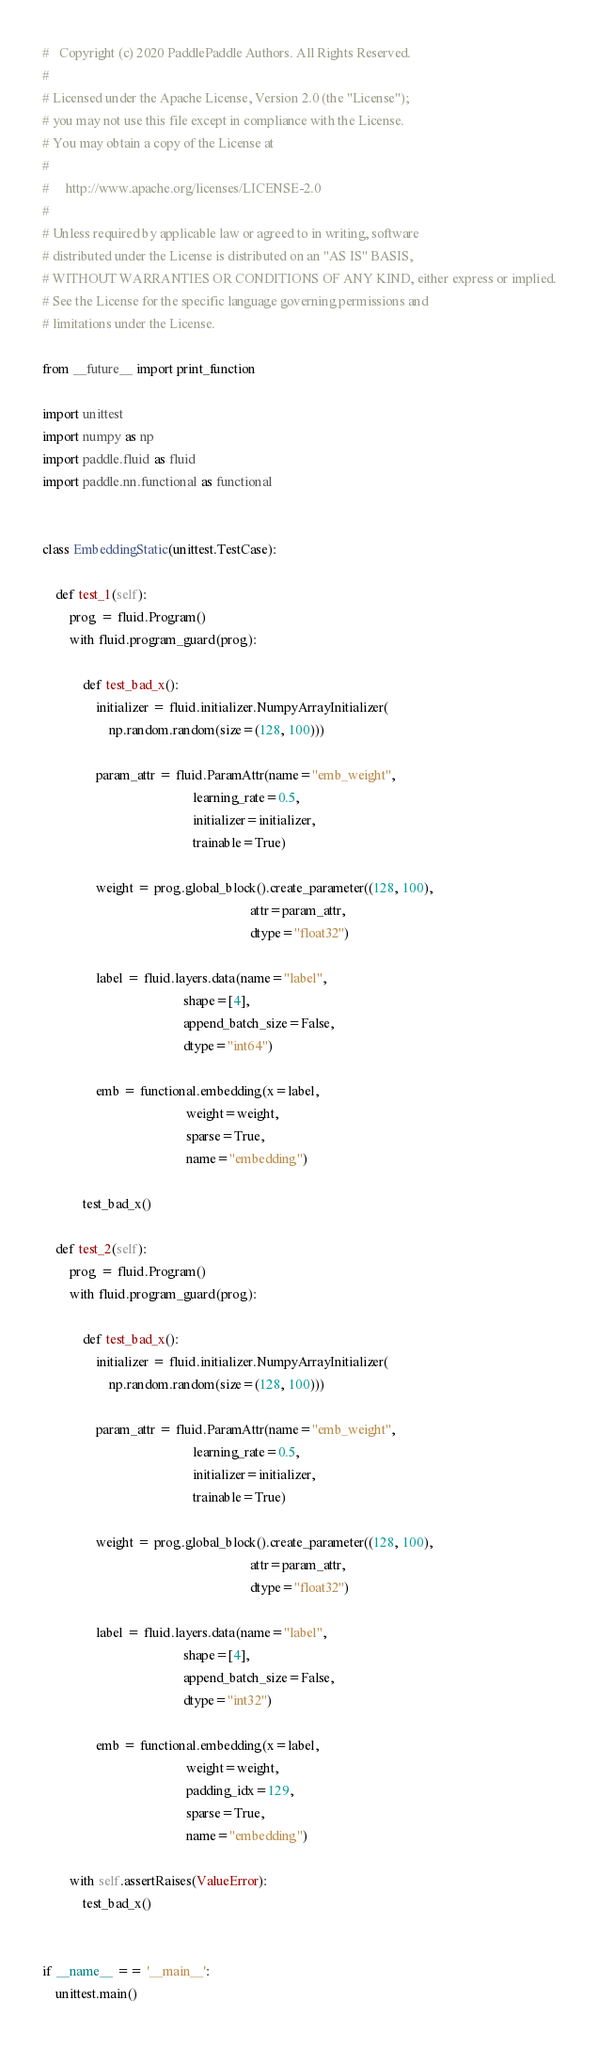<code> <loc_0><loc_0><loc_500><loc_500><_Python_>#   Copyright (c) 2020 PaddlePaddle Authors. All Rights Reserved.
#
# Licensed under the Apache License, Version 2.0 (the "License");
# you may not use this file except in compliance with the License.
# You may obtain a copy of the License at
#
#     http://www.apache.org/licenses/LICENSE-2.0
#
# Unless required by applicable law or agreed to in writing, software
# distributed under the License is distributed on an "AS IS" BASIS,
# WITHOUT WARRANTIES OR CONDITIONS OF ANY KIND, either express or implied.
# See the License for the specific language governing permissions and
# limitations under the License.

from __future__ import print_function

import unittest
import numpy as np
import paddle.fluid as fluid
import paddle.nn.functional as functional


class EmbeddingStatic(unittest.TestCase):

    def test_1(self):
        prog = fluid.Program()
        with fluid.program_guard(prog):

            def test_bad_x():
                initializer = fluid.initializer.NumpyArrayInitializer(
                    np.random.random(size=(128, 100)))

                param_attr = fluid.ParamAttr(name="emb_weight",
                                             learning_rate=0.5,
                                             initializer=initializer,
                                             trainable=True)

                weight = prog.global_block().create_parameter((128, 100),
                                                              attr=param_attr,
                                                              dtype="float32")

                label = fluid.layers.data(name="label",
                                          shape=[4],
                                          append_batch_size=False,
                                          dtype="int64")

                emb = functional.embedding(x=label,
                                           weight=weight,
                                           sparse=True,
                                           name="embedding")

            test_bad_x()

    def test_2(self):
        prog = fluid.Program()
        with fluid.program_guard(prog):

            def test_bad_x():
                initializer = fluid.initializer.NumpyArrayInitializer(
                    np.random.random(size=(128, 100)))

                param_attr = fluid.ParamAttr(name="emb_weight",
                                             learning_rate=0.5,
                                             initializer=initializer,
                                             trainable=True)

                weight = prog.global_block().create_parameter((128, 100),
                                                              attr=param_attr,
                                                              dtype="float32")

                label = fluid.layers.data(name="label",
                                          shape=[4],
                                          append_batch_size=False,
                                          dtype="int32")

                emb = functional.embedding(x=label,
                                           weight=weight,
                                           padding_idx=129,
                                           sparse=True,
                                           name="embedding")

        with self.assertRaises(ValueError):
            test_bad_x()


if __name__ == '__main__':
    unittest.main()
</code> 